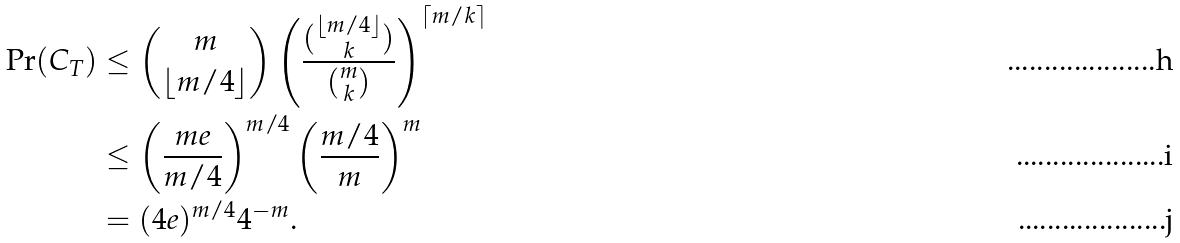Convert formula to latex. <formula><loc_0><loc_0><loc_500><loc_500>\Pr ( C _ { T } ) & \leq \binom { m } { \lfloor m / 4 \rfloor } \left ( \frac { \binom { \lfloor m / 4 \rfloor } { k } } { \binom { m } { k } } \right ) ^ { \lceil m / k \rceil } \\ & \leq \left ( \frac { m e } { m / 4 } \right ) ^ { m / 4 } \left ( \frac { m / 4 } { m } \right ) ^ { m } \\ & = ( 4 e ) ^ { m / 4 } 4 ^ { - m } .</formula> 